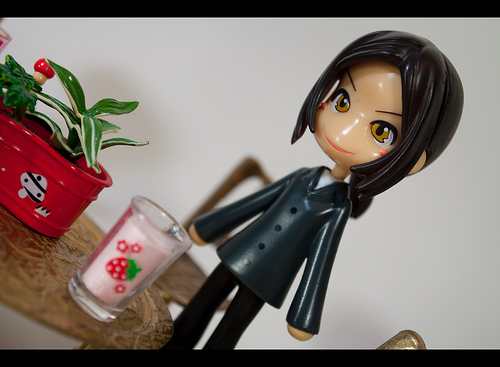<image>
Is the doll on the cup? No. The doll is not positioned on the cup. They may be near each other, but the doll is not supported by or resting on top of the cup. 